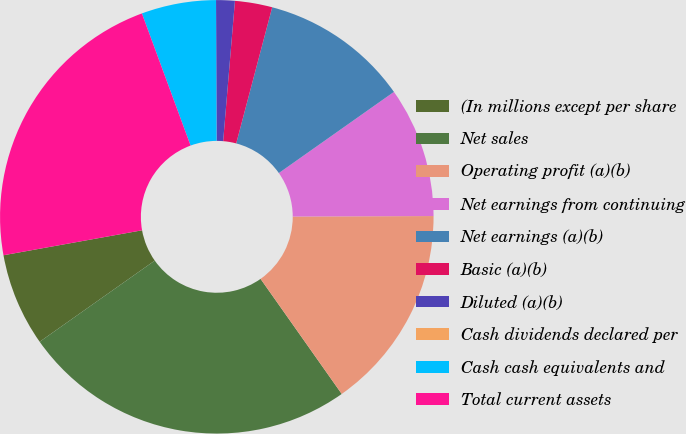Convert chart to OTSL. <chart><loc_0><loc_0><loc_500><loc_500><pie_chart><fcel>(In millions except per share<fcel>Net sales<fcel>Operating profit (a)(b)<fcel>Net earnings from continuing<fcel>Net earnings (a)(b)<fcel>Basic (a)(b)<fcel>Diluted (a)(b)<fcel>Cash dividends declared per<fcel>Cash cash equivalents and<fcel>Total current assets<nl><fcel>6.94%<fcel>25.0%<fcel>15.28%<fcel>9.72%<fcel>11.11%<fcel>2.78%<fcel>1.39%<fcel>0.0%<fcel>5.56%<fcel>22.22%<nl></chart> 